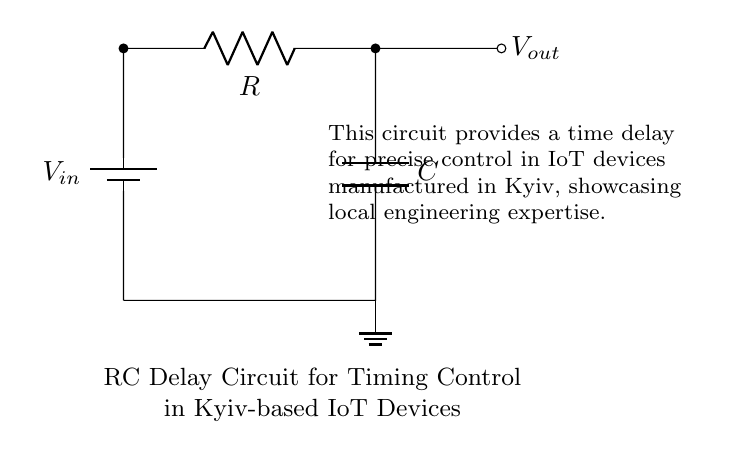What are the components of this circuit? The circuit consists of a resistor and a capacitor, indicated by the labels R and C. There is also a voltage source labeled Vin.
Answer: Resistor and Capacitor What is the output voltage labeled in the circuit? The output voltage is labeled Vout, which is the point from where the delayed signal can be taken.
Answer: Vout What does the RC circuit provide in terms of timing control? The RC circuit provides a time delay for precise control in IoT devices, as described in the explanatory text.
Answer: Time delay How is the capacitor connected in the circuit? The capacitor is connected in parallel with the resistor and is part of a feedback loop for timing control, influencing how the output voltage changes over time.
Answer: In parallel How does the resistor affect the timing of the circuit? The resistor controls the charge and discharge rate of the capacitor, thus affecting the overall time constant of the RC circuit, which determines the delay in the output voltage.
Answer: Controls charge rate What is the purpose of the ground in this circuit? The ground acts as a reference point for the circuit, ensuring that the voltage levels are stable and allowing for proper functioning of the RC timing mechanism.
Answer: Reference point What defines the timing characteristics of this RC circuit? The timing characteristics are primarily defined by the values of the resistor R and the capacitor C, which together determine the time constant τ equal to R multiplied by C.
Answer: R and C values 